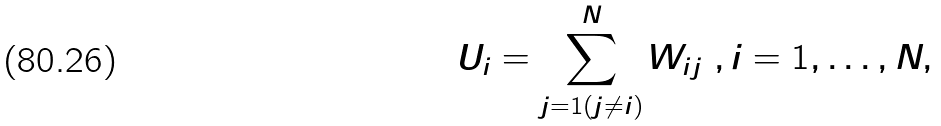Convert formula to latex. <formula><loc_0><loc_0><loc_500><loc_500>U _ { i } = \sum _ { j = 1 ( j \ne i ) } ^ { N } W _ { i j } \ , i = 1 , \dots , N ,</formula> 